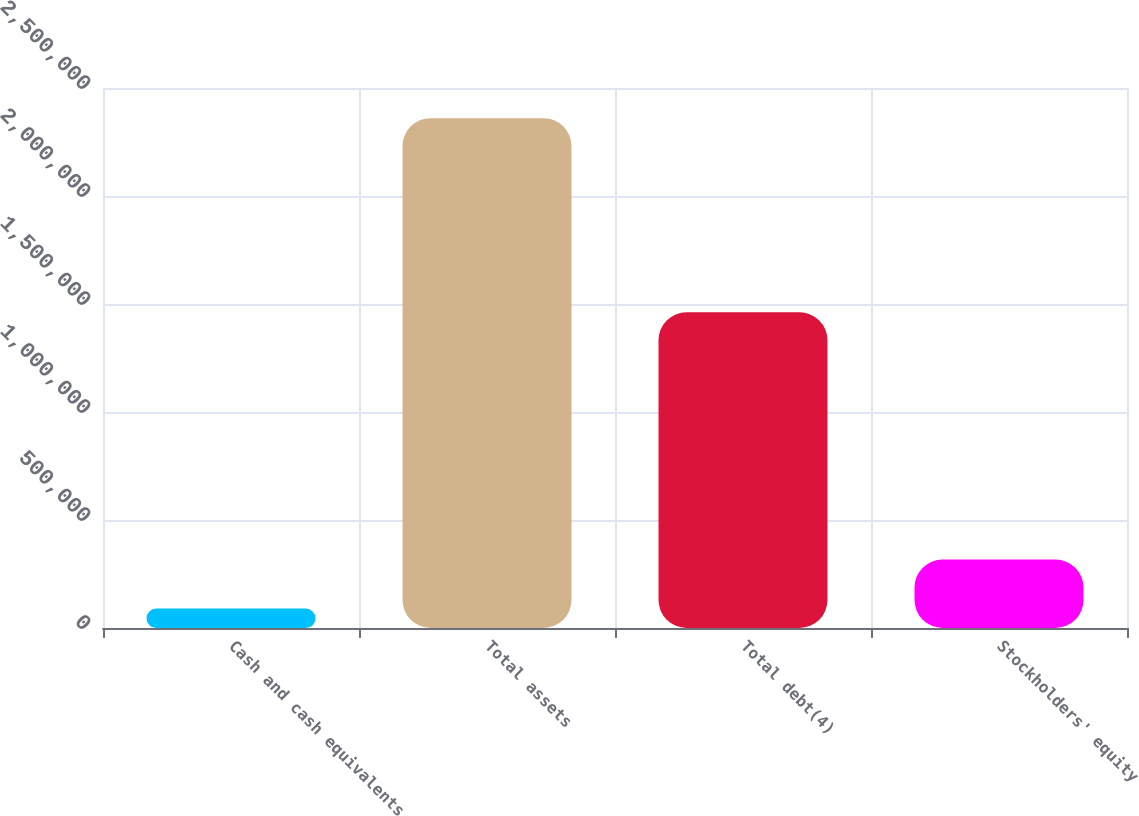Convert chart to OTSL. <chart><loc_0><loc_0><loc_500><loc_500><bar_chart><fcel>Cash and cash equivalents<fcel>Total assets<fcel>Total debt(4)<fcel>Stockholders' equity<nl><fcel>89819<fcel>2.36034e+06<fcel>1.46142e+06<fcel>316871<nl></chart> 